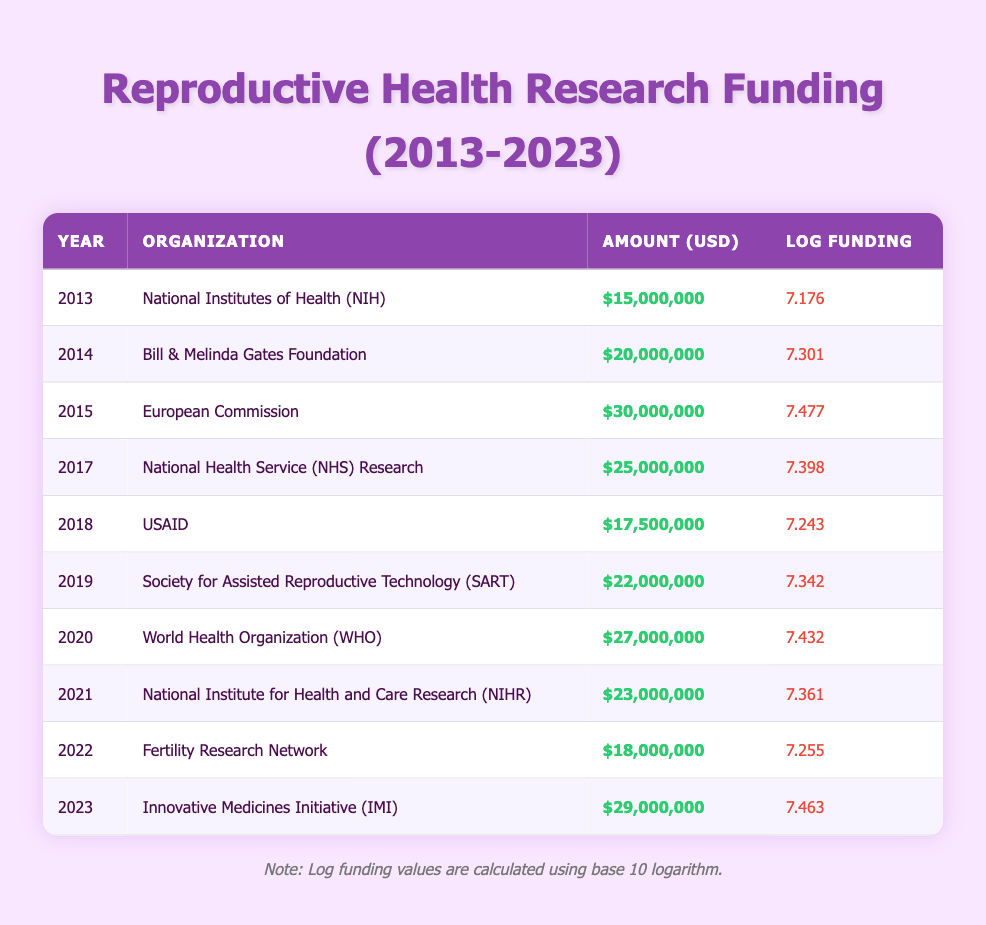What was the total research funding amount in 2014? The table indicates that the funding amount for 2014 by the Bill & Melinda Gates Foundation was $20,000,000.
Answer: $20,000,000 Which organization provided funding in 2019? The funding organization listed for 2019 is the Society for Assisted Reproductive Technology (SART).
Answer: Society for Assisted Reproductive Technology (SART) What is the difference in funding between 2015 and 2017? The funding amount in 2015 was $30,000,000, and in 2017 was $25,000,000. The difference is $30,000,000 - $25,000,000 = $5,000,000.
Answer: $5,000,000 Did the National Institutes of Health (NIH) provide more funding in 2013 than the Fertility Research Network did in 2022? The NIH funding in 2013 was $15,000,000, while the Fertility Research Network's funding in 2022 was $18,000,000. Therefore, the NIH did not provide more funding.
Answer: No What is the average funding amount over the years listed in the table? First, sum all the amounts: $15,000,000 + $20,000,000 + $30,000,000 + $25,000,000 + $17,500,000 + $22,000,000 + $27,000,000 + $23,000,000 + $18,000,000 + $29,000,000 = $ 236,500,000. There are 10 years of funding, so the average is $236,500,000 / 10 = $23,650,000.
Answer: $23,650,000 Which year had the highest logarithmic funding value? The table shows that the highest log funding value is 7.477, which corresponds to the year 2015 when funded by the European Commission.
Answer: 2015 